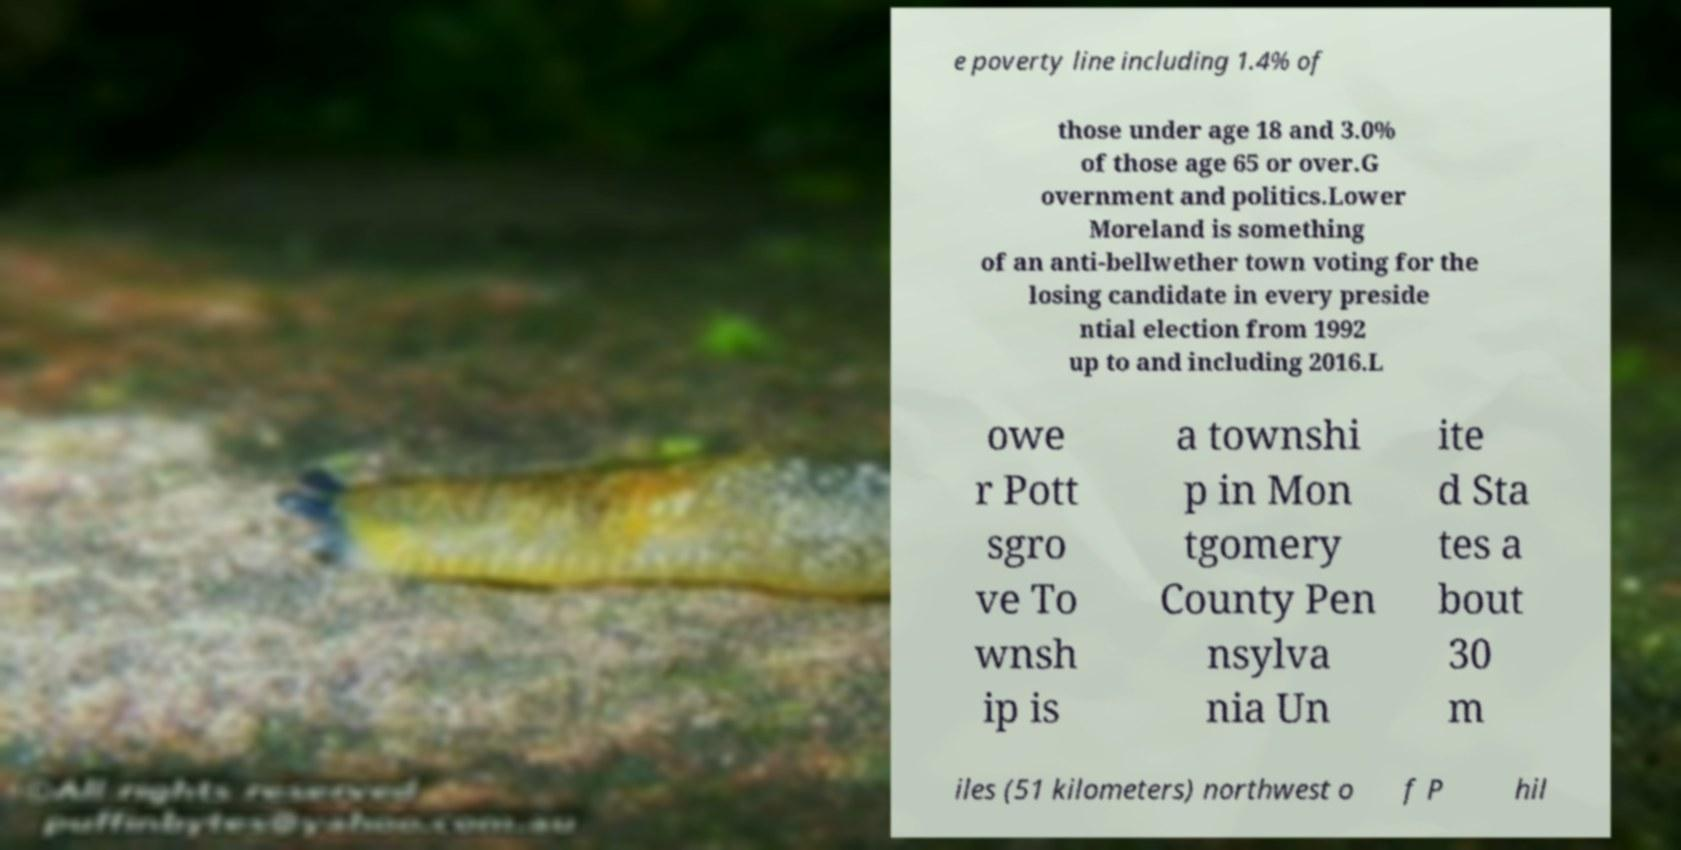What messages or text are displayed in this image? I need them in a readable, typed format. e poverty line including 1.4% of those under age 18 and 3.0% of those age 65 or over.G overnment and politics.Lower Moreland is something of an anti-bellwether town voting for the losing candidate in every preside ntial election from 1992 up to and including 2016.L owe r Pott sgro ve To wnsh ip is a townshi p in Mon tgomery County Pen nsylva nia Un ite d Sta tes a bout 30 m iles (51 kilometers) northwest o f P hil 